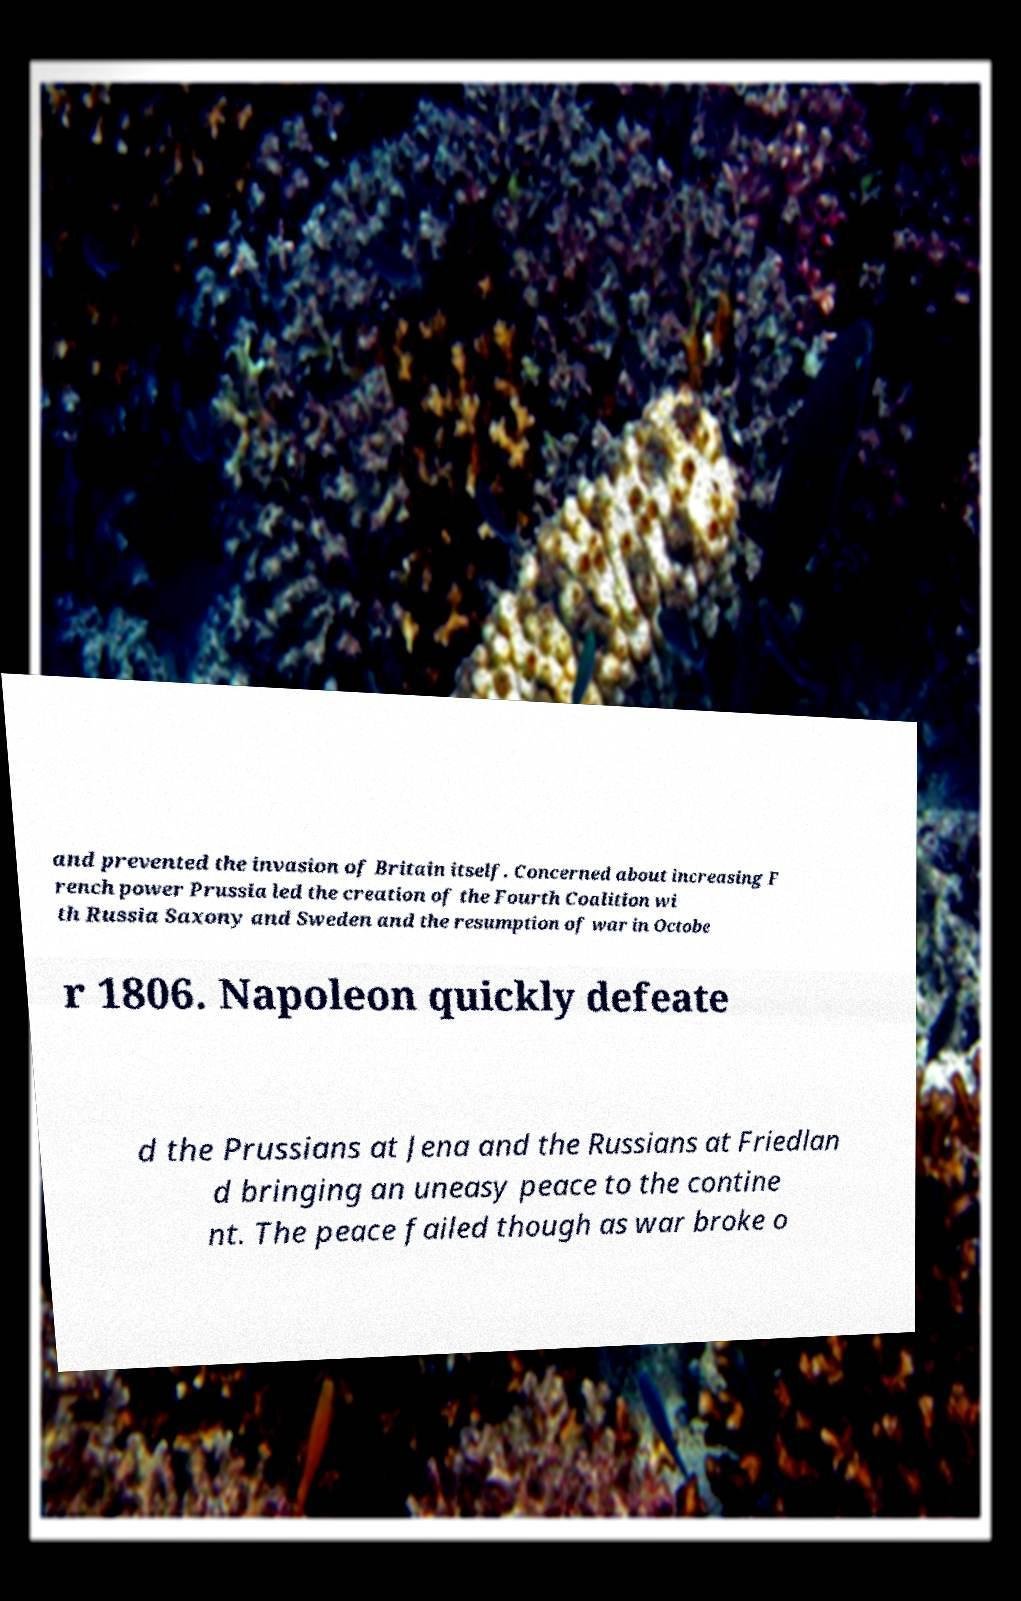Please identify and transcribe the text found in this image. and prevented the invasion of Britain itself. Concerned about increasing F rench power Prussia led the creation of the Fourth Coalition wi th Russia Saxony and Sweden and the resumption of war in Octobe r 1806. Napoleon quickly defeate d the Prussians at Jena and the Russians at Friedlan d bringing an uneasy peace to the contine nt. The peace failed though as war broke o 